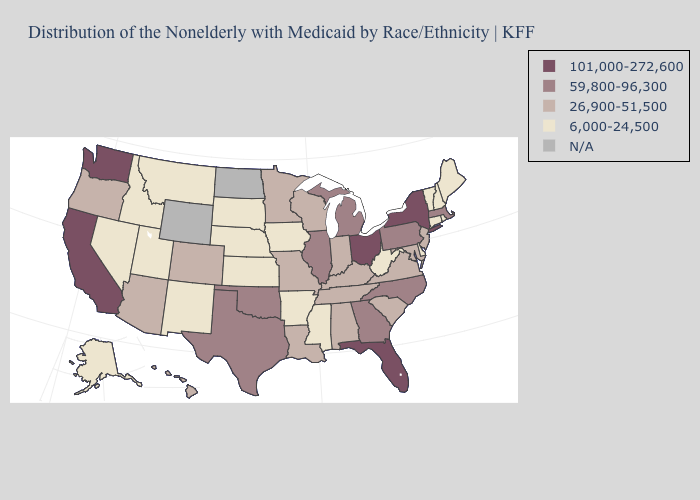What is the value of Washington?
Answer briefly. 101,000-272,600. Among the states that border Tennessee , which have the highest value?
Concise answer only. Georgia, North Carolina. What is the value of North Dakota?
Answer briefly. N/A. What is the lowest value in states that border Wyoming?
Concise answer only. 6,000-24,500. Name the states that have a value in the range 101,000-272,600?
Short answer required. California, Florida, New York, Ohio, Washington. What is the highest value in the USA?
Be succinct. 101,000-272,600. Name the states that have a value in the range 26,900-51,500?
Give a very brief answer. Alabama, Arizona, Colorado, Hawaii, Indiana, Kentucky, Louisiana, Maryland, Minnesota, Missouri, New Jersey, Oregon, South Carolina, Tennessee, Virginia, Wisconsin. What is the value of Illinois?
Give a very brief answer. 59,800-96,300. What is the value of Hawaii?
Write a very short answer. 26,900-51,500. What is the value of West Virginia?
Quick response, please. 6,000-24,500. Which states have the lowest value in the MidWest?
Give a very brief answer. Iowa, Kansas, Nebraska, South Dakota. Does the map have missing data?
Be succinct. Yes. What is the lowest value in states that border Minnesota?
Short answer required. 6,000-24,500. What is the value of Nebraska?
Be succinct. 6,000-24,500. 